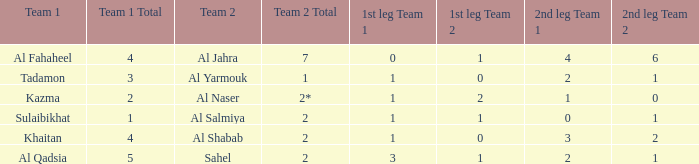What is the 1st leg of the Al Fahaheel Team 1? 0–1. Write the full table. {'header': ['Team 1', 'Team 1 Total', 'Team 2', 'Team 2 Total', '1st leg Team 1', '1st leg Team 2', '2nd leg Team 1', '2nd leg Team 2'], 'rows': [['Al Fahaheel', '4', 'Al Jahra', '7', '0', '1', '4', '6'], ['Tadamon', '3', 'Al Yarmouk', '1', '1', '0', '2', '1'], ['Kazma', '2', 'Al Naser', '2*', '1', '2', '1', '0'], ['Sulaibikhat', '1', 'Al Salmiya', '2', '1', '1', '0', '1'], ['Khaitan', '4', 'Al Shabab', '2', '1', '0', '3', '2'], ['Al Qadsia', '5', 'Sahel', '2', '3', '1', '2', '1']]} 